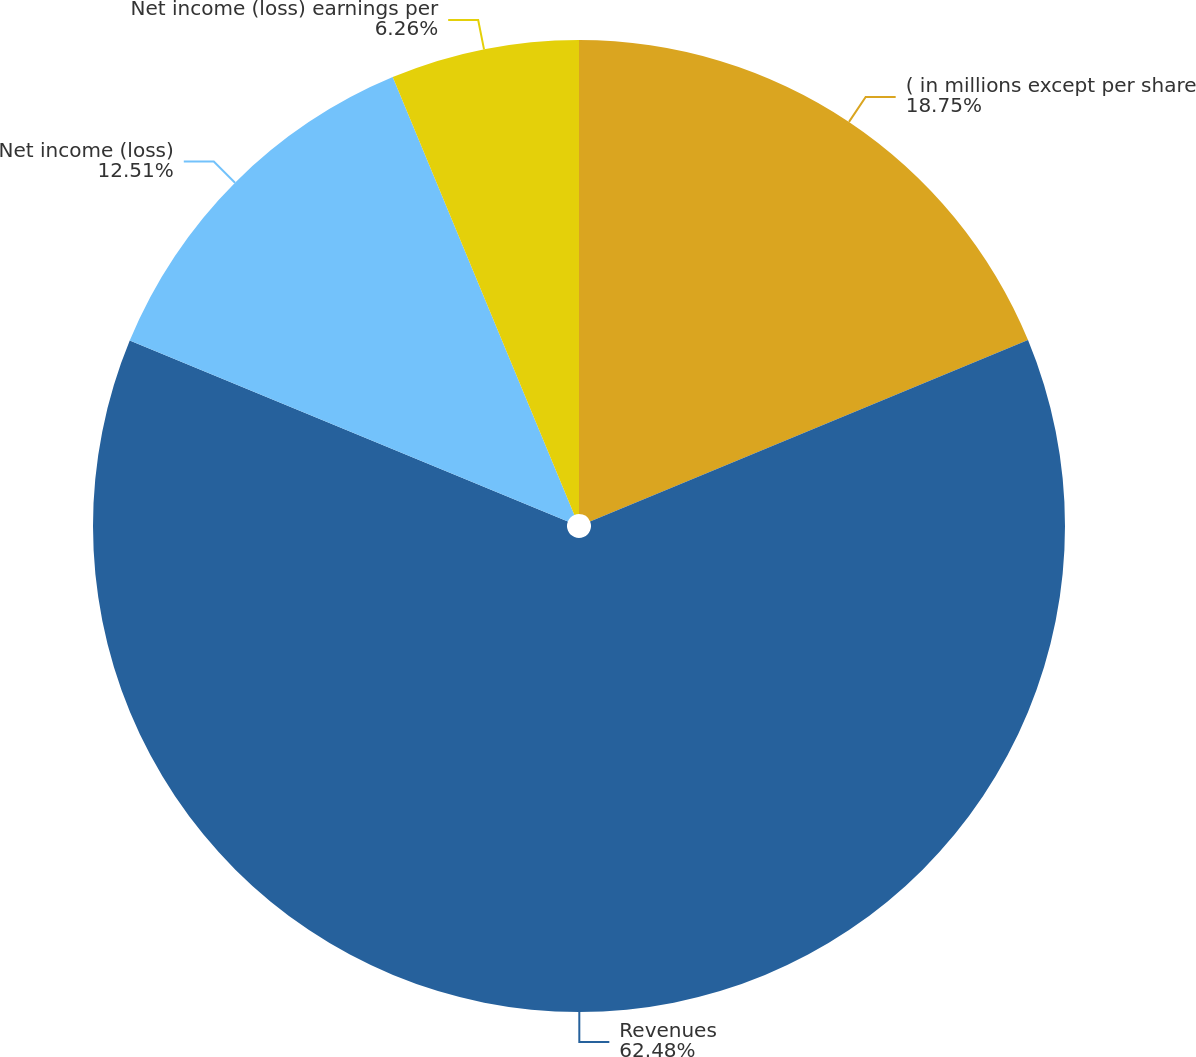Convert chart. <chart><loc_0><loc_0><loc_500><loc_500><pie_chart><fcel>( in millions except per share<fcel>Revenues<fcel>Net income (loss)<fcel>Net income (loss) earnings per<nl><fcel>18.75%<fcel>62.48%<fcel>12.51%<fcel>6.26%<nl></chart> 